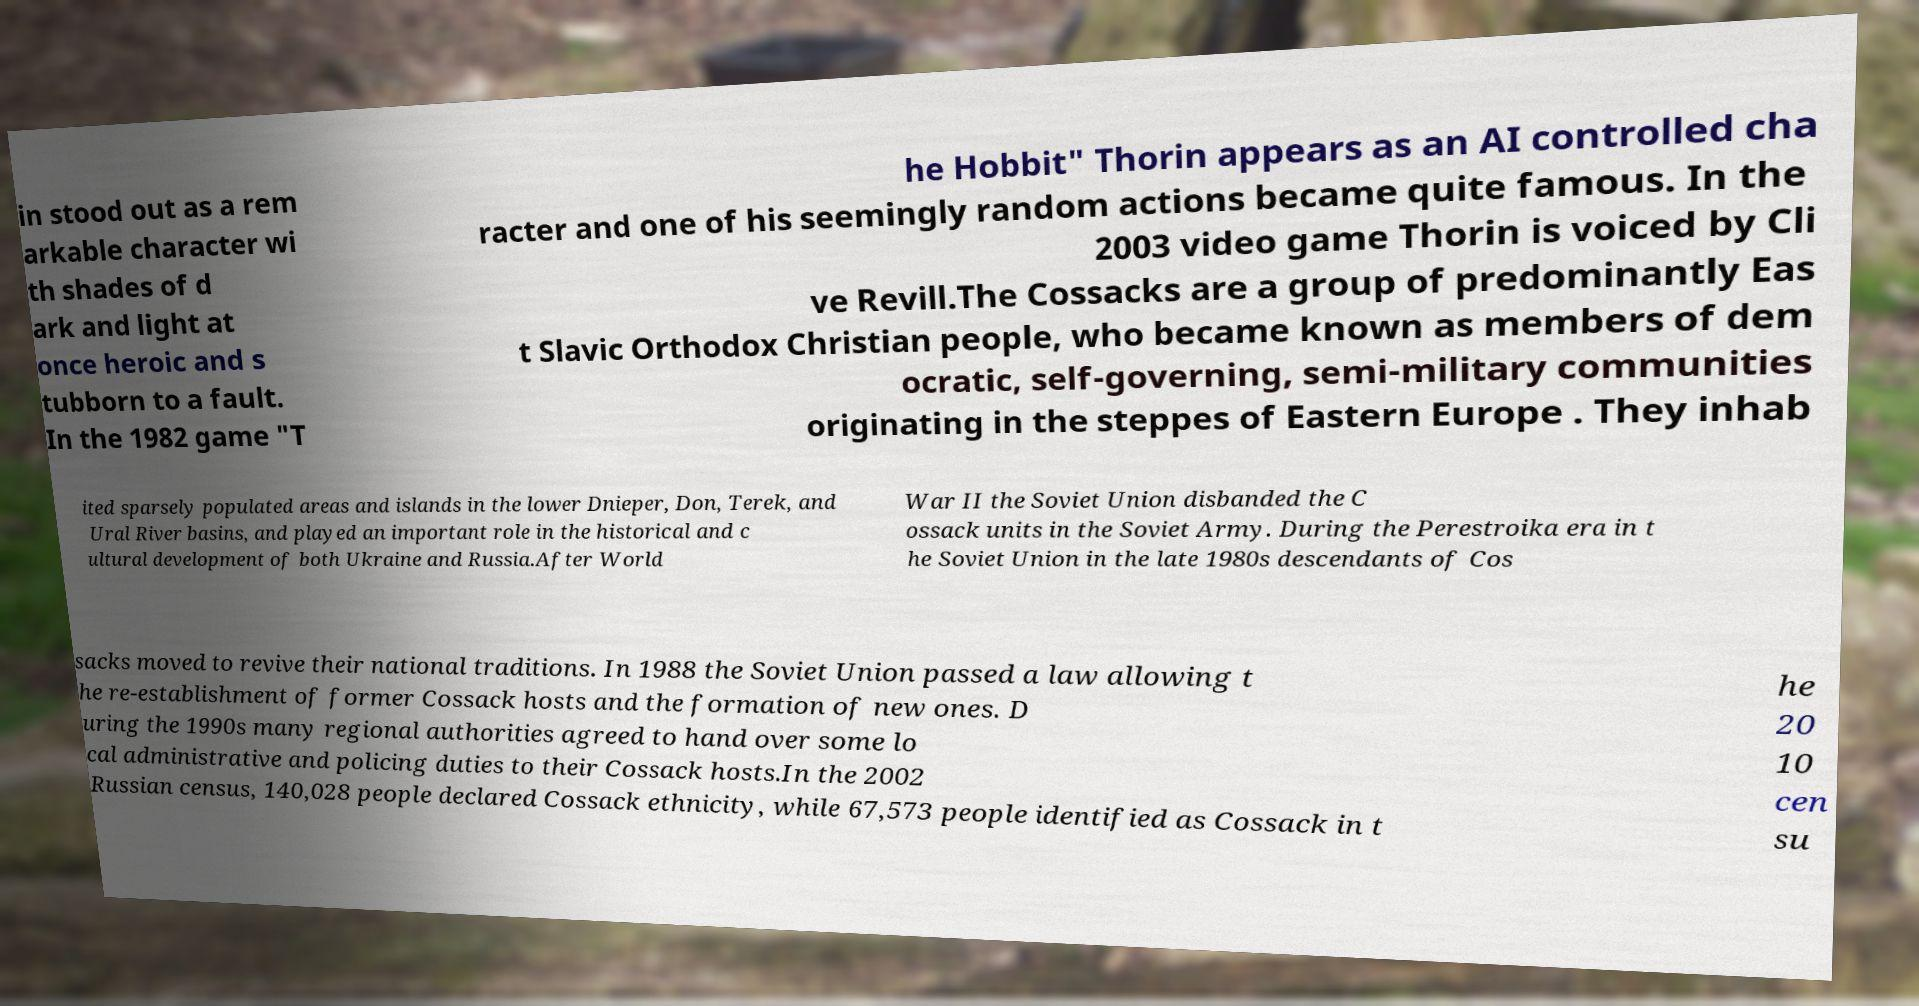Please read and relay the text visible in this image. What does it say? in stood out as a rem arkable character wi th shades of d ark and light at once heroic and s tubborn to a fault. In the 1982 game "T he Hobbit" Thorin appears as an AI controlled cha racter and one of his seemingly random actions became quite famous. In the 2003 video game Thorin is voiced by Cli ve Revill.The Cossacks are a group of predominantly Eas t Slavic Orthodox Christian people, who became known as members of dem ocratic, self-governing, semi-military communities originating in the steppes of Eastern Europe . They inhab ited sparsely populated areas and islands in the lower Dnieper, Don, Terek, and Ural River basins, and played an important role in the historical and c ultural development of both Ukraine and Russia.After World War II the Soviet Union disbanded the C ossack units in the Soviet Army. During the Perestroika era in t he Soviet Union in the late 1980s descendants of Cos sacks moved to revive their national traditions. In 1988 the Soviet Union passed a law allowing t he re-establishment of former Cossack hosts and the formation of new ones. D uring the 1990s many regional authorities agreed to hand over some lo cal administrative and policing duties to their Cossack hosts.In the 2002 Russian census, 140,028 people declared Cossack ethnicity, while 67,573 people identified as Cossack in t he 20 10 cen su 